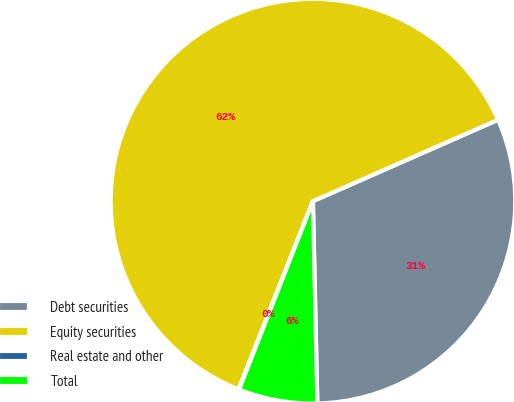Convert chart. <chart><loc_0><loc_0><loc_500><loc_500><pie_chart><fcel>Debt securities<fcel>Equity securities<fcel>Real estate and other<fcel>Total<nl><fcel>31.25%<fcel>62.41%<fcel>0.05%<fcel>6.29%<nl></chart> 